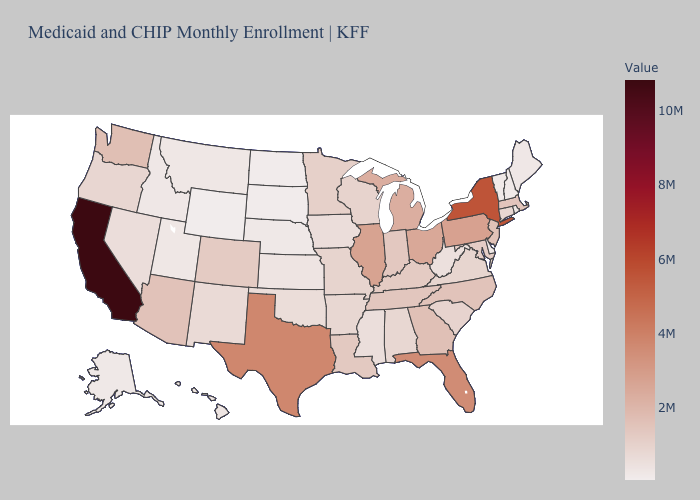Does California have the highest value in the USA?
Short answer required. Yes. Among the states that border Georgia , which have the lowest value?
Give a very brief answer. Alabama. Is the legend a continuous bar?
Write a very short answer. Yes. Which states have the lowest value in the USA?
Write a very short answer. Wyoming. Among the states that border Ohio , does Indiana have the highest value?
Answer briefly. No. 